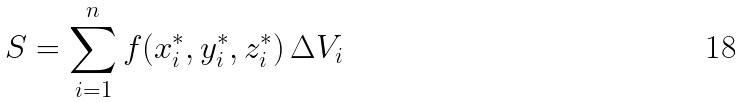Convert formula to latex. <formula><loc_0><loc_0><loc_500><loc_500>S = \sum _ { i = 1 } ^ { n } f ( x _ { i } ^ { * } , y _ { i } ^ { * } , z _ { i } ^ { * } ) \, \Delta V _ { i }</formula> 